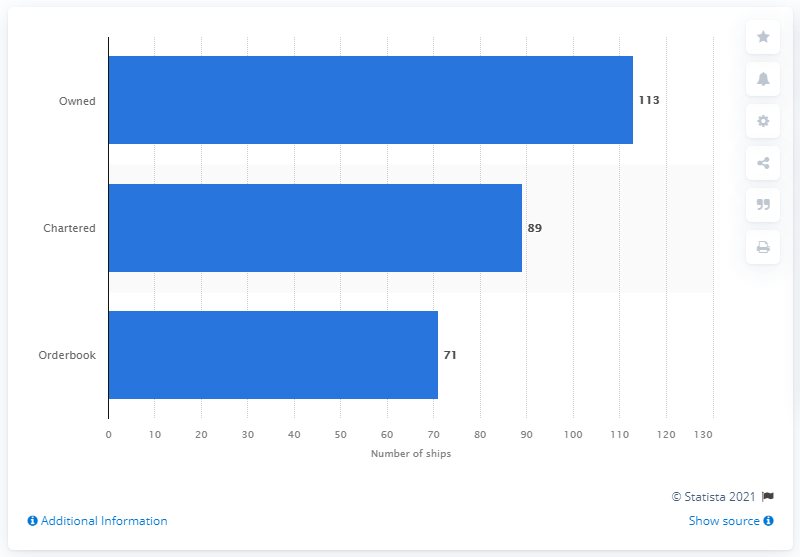Indicate a few pertinent items in this graphic. As of June 14, 2021, Evergreen had a total of 89 chartered ships in its fleet. 